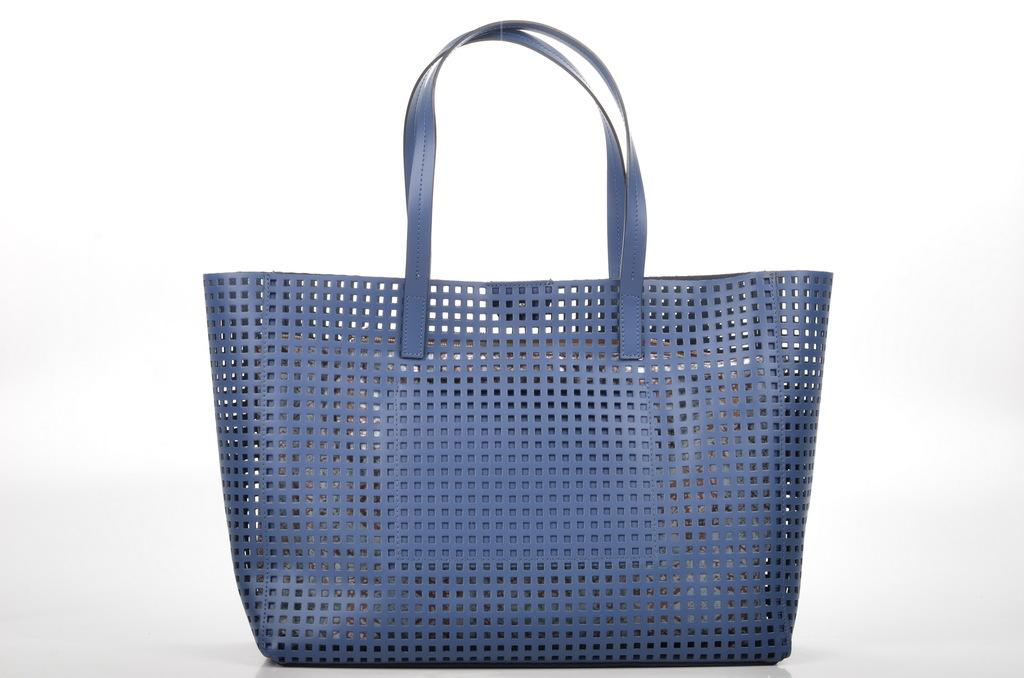What type of handbag is visible in the image? There is a blue handbag in the image. Are there any unique features on the handbag? Yes, the handbag has small holes in it. Where is the plantation located in the image? There is no plantation present in the image. What type of rod can be seen holding up the clock in the image? There is no clock or rod present in the image. 